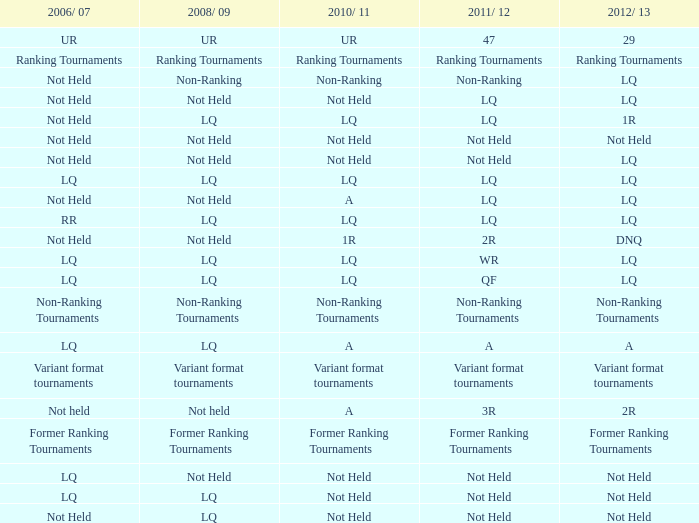What is 2006/07, when 2011/12 is LQ, and when 2010/11 is LQ? Not Held, LQ, RR. 